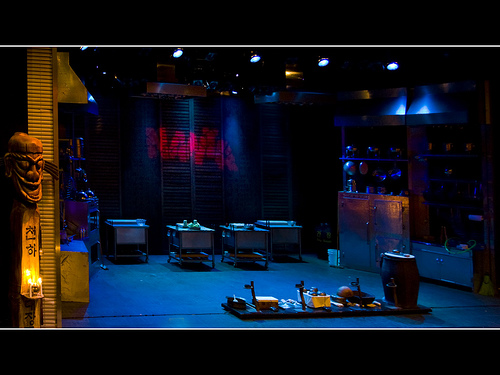<image>
Is the mask on the door? Yes. Looking at the image, I can see the mask is positioned on top of the door, with the door providing support. Is there a light on the ceiling? Yes. Looking at the image, I can see the light is positioned on top of the ceiling, with the ceiling providing support. 